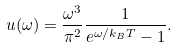Convert formula to latex. <formula><loc_0><loc_0><loc_500><loc_500>u ( { \omega } ) = \frac { \omega ^ { 3 } } { \pi ^ { 2 } } \frac { 1 } { e ^ { \omega / k _ { B } T } - 1 } .</formula> 